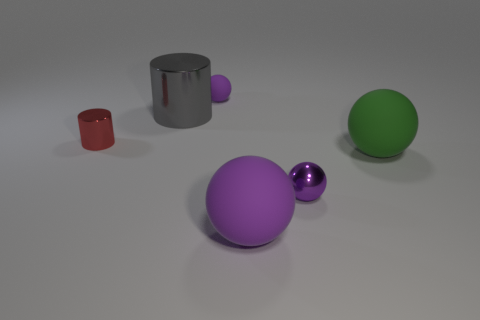What is the size of the rubber object that is the same color as the tiny rubber ball?
Your response must be concise. Large. There is a big object that is in front of the tiny purple sphere in front of the tiny rubber thing; is there a purple thing that is on the right side of it?
Your answer should be very brief. Yes. How many large things are left of the large purple ball?
Ensure brevity in your answer.  1. How many large spheres have the same color as the small matte thing?
Provide a succinct answer. 1. What number of objects are either small purple objects in front of the big gray shiny object or tiny shiny things in front of the tiny red cylinder?
Give a very brief answer. 1. Are there more big things than spheres?
Give a very brief answer. No. What is the color of the tiny metallic object that is behind the purple shiny thing?
Offer a very short reply. Red. Do the large gray object and the tiny red shiny object have the same shape?
Your answer should be very brief. Yes. What is the color of the small object that is in front of the small purple rubber thing and behind the green thing?
Offer a terse response. Red. There is a purple rubber sphere on the right side of the small rubber object; does it have the same size as the metal thing behind the red thing?
Give a very brief answer. Yes. 